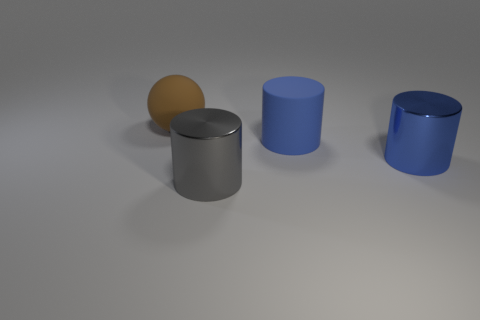Could you infer the possible material of the sphere, and how does it contrast with the cylinders? The sphere's matte and slightly textured surface suggests it could be made of a material like clay or rubber, contrasting with the cylinders that have a more reflective surface, which indicates they might be made of metal or a similarly shiny material. 